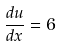Convert formula to latex. <formula><loc_0><loc_0><loc_500><loc_500>\frac { d u } { d x } = 6</formula> 